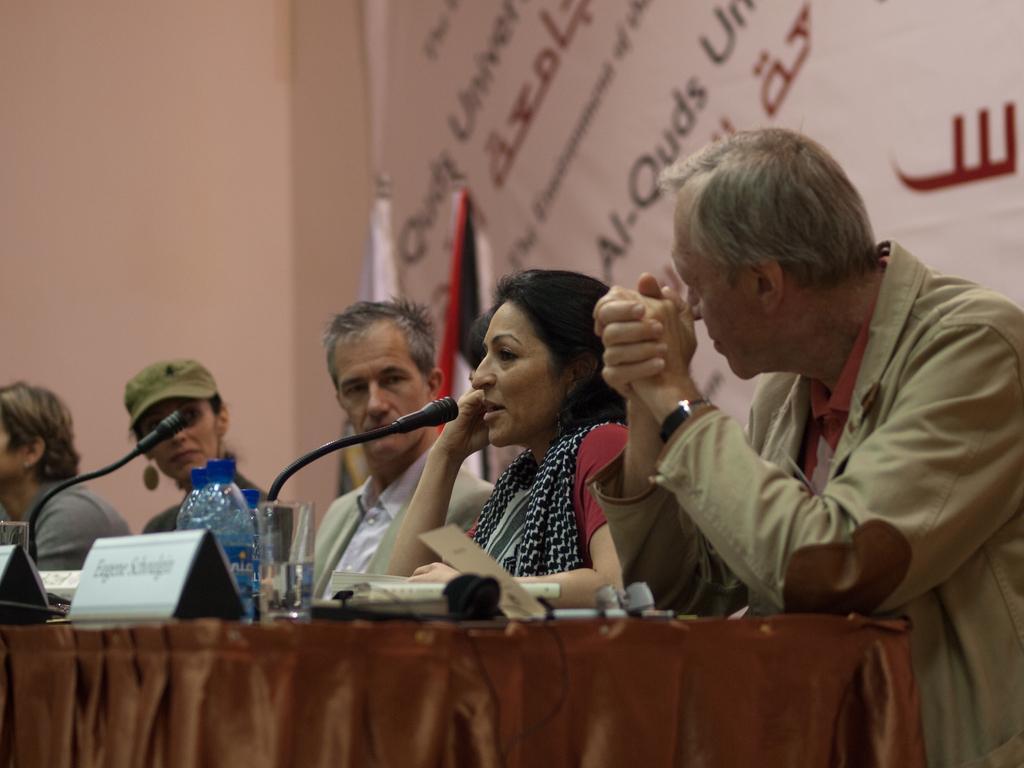In one or two sentences, can you explain what this image depicts? In this picture we can see people. On a table we can see name boards, microphones, bottled, water glass and objects. At the bottom portion of the picture we can see a cloth. On the right side of the picture we can see the wall, banner and flags. We can see a woman and she is talking. 